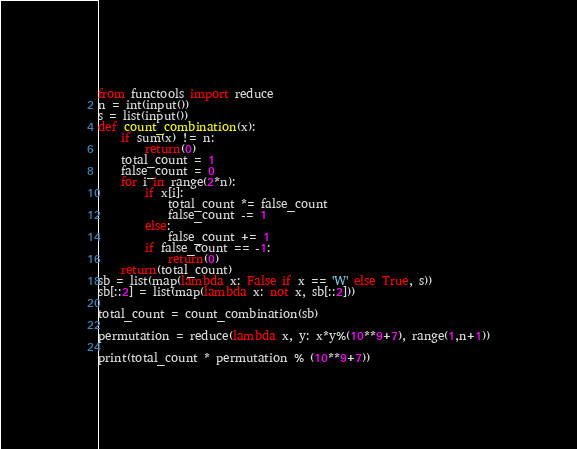Convert code to text. <code><loc_0><loc_0><loc_500><loc_500><_Python_>from functools import reduce
n = int(input())
s = list(input())
def count_combination(x):
    if sum(x) != n:
        return(0)
    total_count = 1
    false_count = 0
    for i in range(2*n):
        if x[i]:
            total_count *= false_count
            false_count -= 1
        else:
            false_count += 1
        if false_count == -1:
            return(0)
    return(total_count)
sb = list(map(lambda x: False if x == 'W' else True, s))
sb[::2] = list(map(lambda x: not x, sb[::2]))

total_count = count_combination(sb)

permutation = reduce(lambda x, y: x*y%(10**9+7), range(1,n+1))

print(total_count * permutation % (10**9+7))</code> 